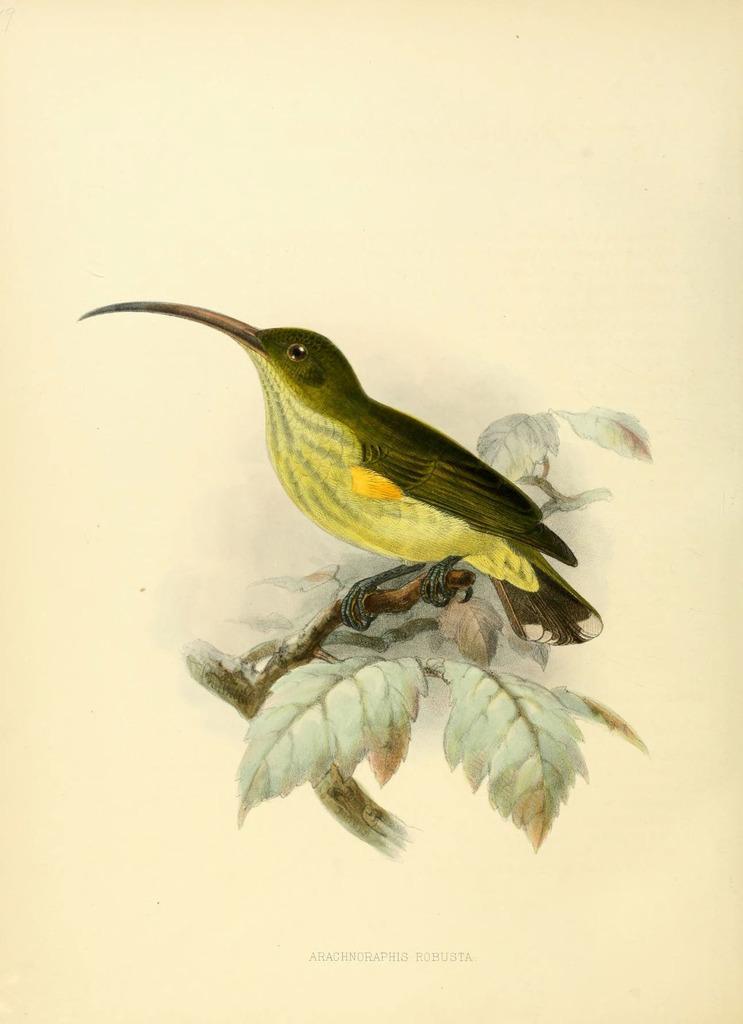How would you summarize this image in a sentence or two? In this image, we can see depiction of a bird and leaves on the yellow background. 